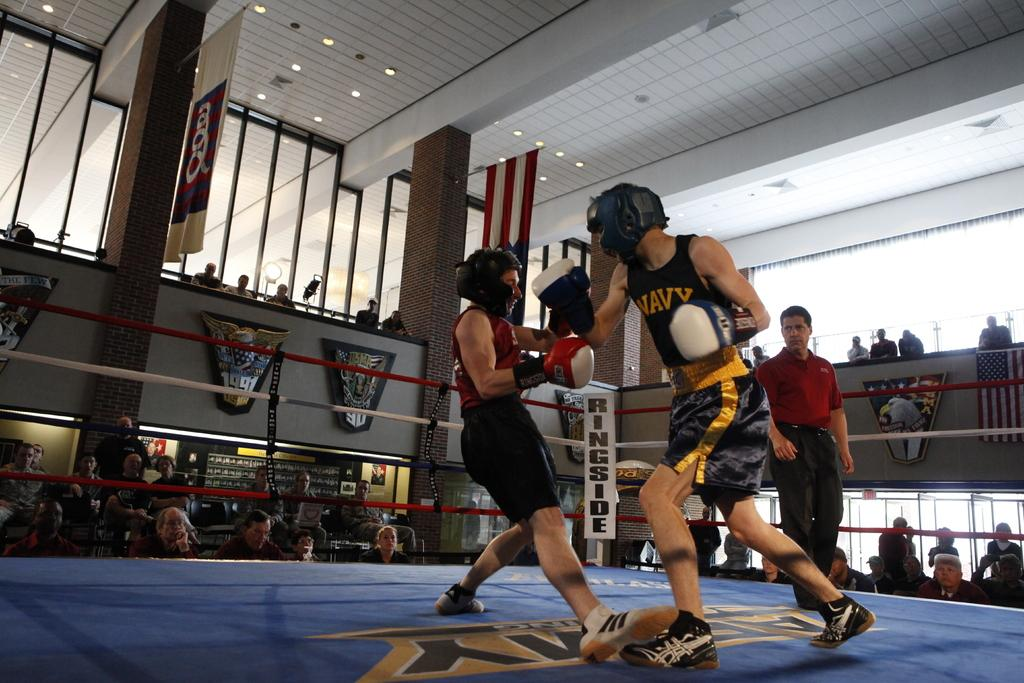<image>
Write a terse but informative summary of the picture. Boxing match between 2 fighters, and text on the side that says ringside. 